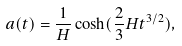<formula> <loc_0><loc_0><loc_500><loc_500>a ( t ) = \frac { 1 } { H } \cosh ( \frac { 2 } { 3 } H t ^ { 3 / 2 } ) ,</formula> 